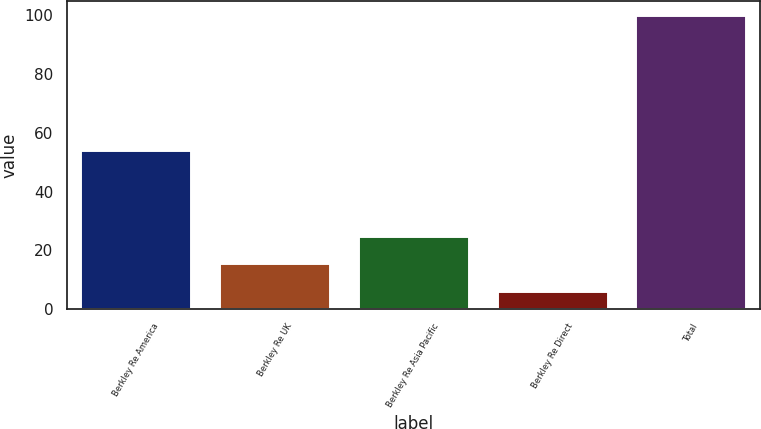Convert chart. <chart><loc_0><loc_0><loc_500><loc_500><bar_chart><fcel>Berkley Re America<fcel>Berkley Re UK<fcel>Berkley Re Asia Pacific<fcel>Berkley Re Direct<fcel>Total<nl><fcel>54.3<fcel>15.58<fcel>24.96<fcel>6.2<fcel>100<nl></chart> 